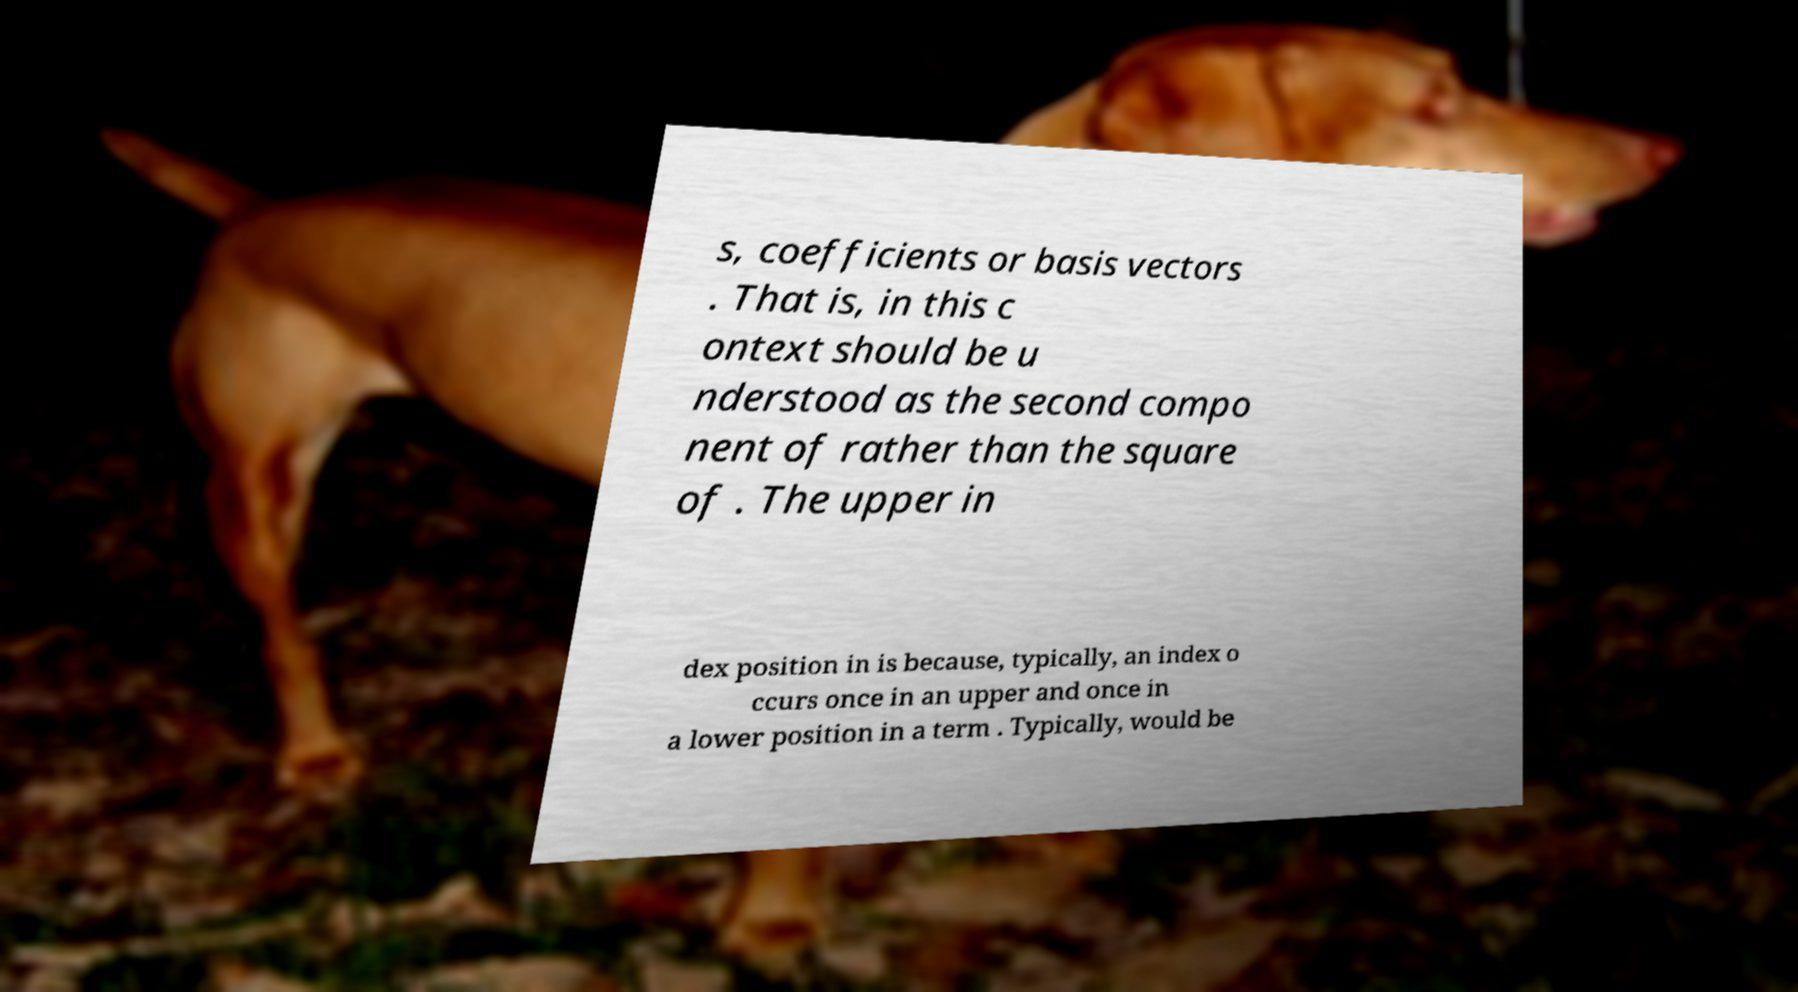Can you accurately transcribe the text from the provided image for me? s, coefficients or basis vectors . That is, in this c ontext should be u nderstood as the second compo nent of rather than the square of . The upper in dex position in is because, typically, an index o ccurs once in an upper and once in a lower position in a term . Typically, would be 